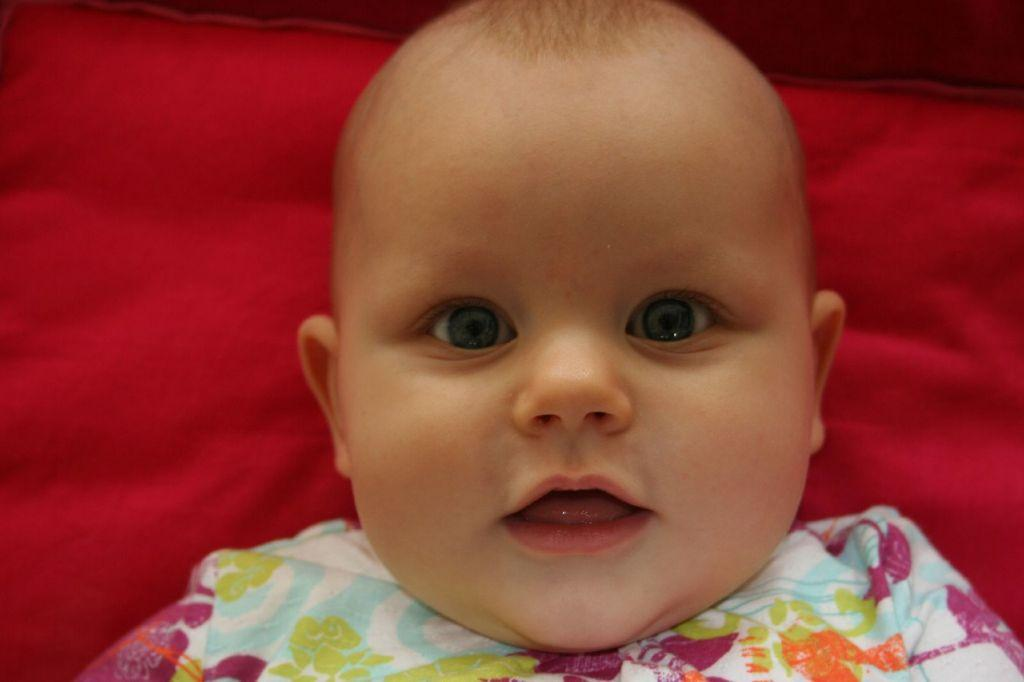What is the main subject of the picture? The main subject of the picture is a baby. Where is the baby positioned in the image? The baby is lying on a pillow. What type of cart is being used to transport the baby in the image? There is no cart present in the image; the baby is lying on a pillow. What religious symbols can be seen in the image? There are no religious symbols present in the image; it features a baby lying on a pillow. 